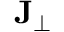Convert formula to latex. <formula><loc_0><loc_0><loc_500><loc_500>J _ { \perp }</formula> 